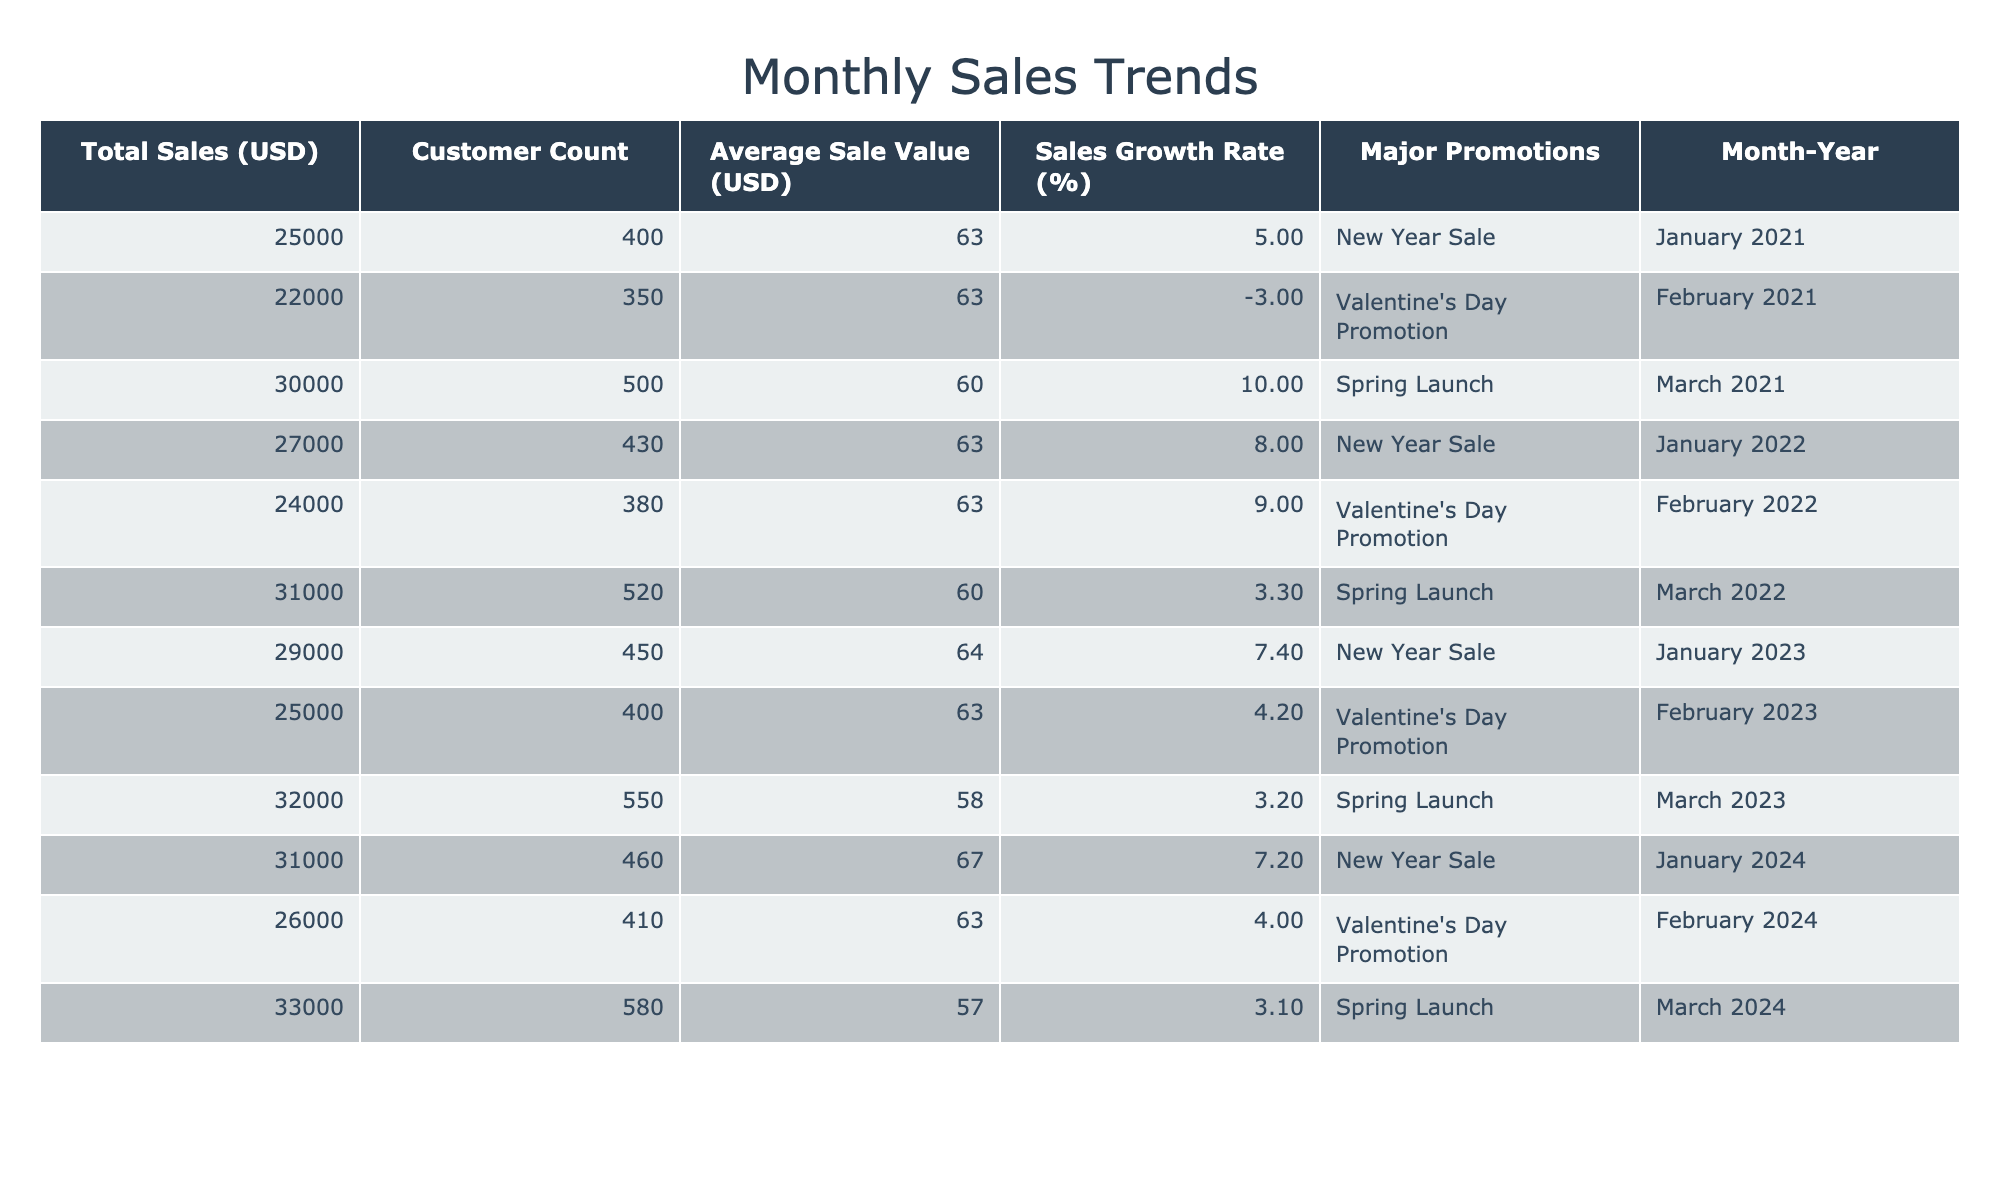What were the total sales in March 2023? The table lists the total sales for March 2023 as 32000 USD.
Answer: 32000 USD Which month in 2024 had the highest sales? In the table, March 2024 has total sales of 33000 USD, which is the highest compared to January and February 2024.
Answer: March 2024 What is the average customer count for January across all years? The customer counts for January are 400 (2021), 430 (2022), 450 (2023), and 460 (2024). To find the average: (400 + 430 + 450 + 460) / 4 = 435.
Answer: 435 Was there a sales growth in February 2023 compared to February 2022? February 2022 had a sales value of 24000 USD, while February 2023 had 25000 USD, which indicates an increase.
Answer: Yes What is the total sales growth rate from January 2021 to January 2024? The sales in January 2021 were 25000 USD, and in January 2024, they were 31000 USD. The growth rate = [(31000 - 25000) / 25000] * 100 = 24%.
Answer: 24% Which year had the lowest average sale value in March? The average sale values in March are 60.00 (2021), 59.62 (2022), 58.18 (2023), and 56.90 (2024). The lowest average sale value is in March 2024 with 56.90.
Answer: March 2024 Did January 2023 see an increase in total sales compared to January 2022? January 2022 had total sales of 27000 USD, while January 2023 had 29000 USD, reflecting an increase.
Answer: Yes What is the total sales for February across all years? The total sales for February are 22000 (2021) + 24000 (2022) + 25000 (2023) + 26000 (2024) = 97000 USD.
Answer: 97000 USD 